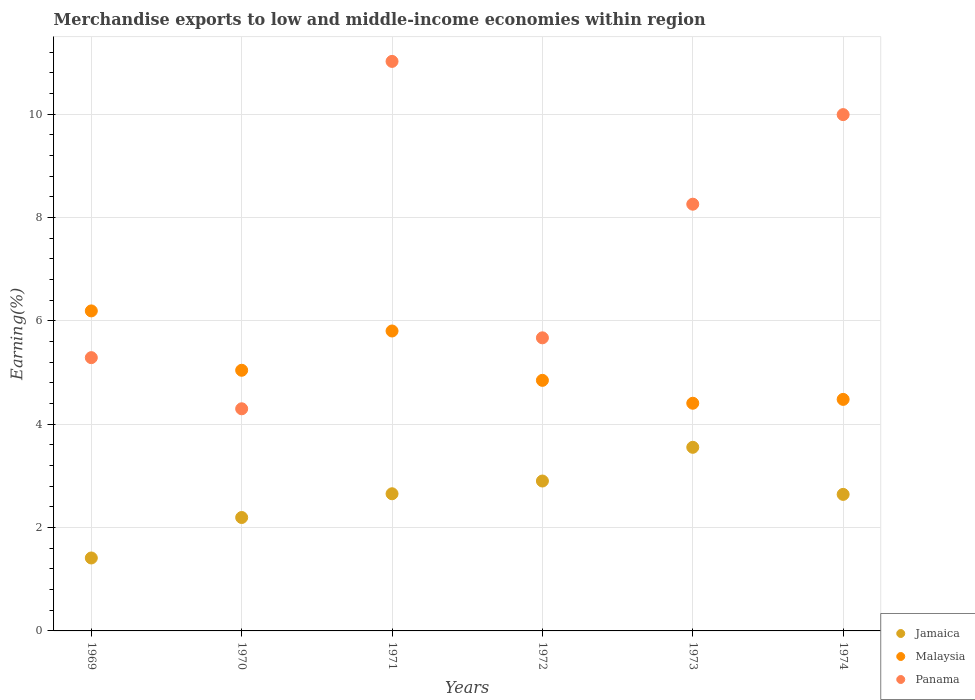Is the number of dotlines equal to the number of legend labels?
Make the answer very short. Yes. What is the percentage of amount earned from merchandise exports in Malaysia in 1971?
Give a very brief answer. 5.81. Across all years, what is the maximum percentage of amount earned from merchandise exports in Jamaica?
Your response must be concise. 3.55. Across all years, what is the minimum percentage of amount earned from merchandise exports in Jamaica?
Your answer should be very brief. 1.41. In which year was the percentage of amount earned from merchandise exports in Jamaica maximum?
Offer a terse response. 1973. What is the total percentage of amount earned from merchandise exports in Jamaica in the graph?
Your response must be concise. 15.36. What is the difference between the percentage of amount earned from merchandise exports in Malaysia in 1973 and that in 1974?
Provide a short and direct response. -0.07. What is the difference between the percentage of amount earned from merchandise exports in Panama in 1969 and the percentage of amount earned from merchandise exports in Jamaica in 1970?
Your answer should be very brief. 3.09. What is the average percentage of amount earned from merchandise exports in Panama per year?
Your answer should be compact. 7.42. In the year 1972, what is the difference between the percentage of amount earned from merchandise exports in Panama and percentage of amount earned from merchandise exports in Jamaica?
Give a very brief answer. 2.77. In how many years, is the percentage of amount earned from merchandise exports in Jamaica greater than 5.2 %?
Keep it short and to the point. 0. What is the ratio of the percentage of amount earned from merchandise exports in Jamaica in 1970 to that in 1971?
Provide a short and direct response. 0.83. Is the percentage of amount earned from merchandise exports in Malaysia in 1969 less than that in 1972?
Offer a terse response. No. What is the difference between the highest and the second highest percentage of amount earned from merchandise exports in Malaysia?
Keep it short and to the point. 0.39. What is the difference between the highest and the lowest percentage of amount earned from merchandise exports in Jamaica?
Give a very brief answer. 2.14. In how many years, is the percentage of amount earned from merchandise exports in Malaysia greater than the average percentage of amount earned from merchandise exports in Malaysia taken over all years?
Keep it short and to the point. 2. How many dotlines are there?
Ensure brevity in your answer.  3. How many years are there in the graph?
Provide a succinct answer. 6. What is the difference between two consecutive major ticks on the Y-axis?
Your response must be concise. 2. Does the graph contain grids?
Keep it short and to the point. Yes. Where does the legend appear in the graph?
Keep it short and to the point. Bottom right. What is the title of the graph?
Keep it short and to the point. Merchandise exports to low and middle-income economies within region. Does "Bosnia and Herzegovina" appear as one of the legend labels in the graph?
Keep it short and to the point. No. What is the label or title of the X-axis?
Offer a very short reply. Years. What is the label or title of the Y-axis?
Provide a succinct answer. Earning(%). What is the Earning(%) of Jamaica in 1969?
Ensure brevity in your answer.  1.41. What is the Earning(%) of Malaysia in 1969?
Ensure brevity in your answer.  6.19. What is the Earning(%) in Panama in 1969?
Your response must be concise. 5.29. What is the Earning(%) of Jamaica in 1970?
Your answer should be compact. 2.2. What is the Earning(%) in Malaysia in 1970?
Ensure brevity in your answer.  5.05. What is the Earning(%) of Panama in 1970?
Your answer should be compact. 4.3. What is the Earning(%) of Jamaica in 1971?
Your answer should be compact. 2.65. What is the Earning(%) of Malaysia in 1971?
Your answer should be very brief. 5.81. What is the Earning(%) in Panama in 1971?
Keep it short and to the point. 11.02. What is the Earning(%) of Jamaica in 1972?
Give a very brief answer. 2.9. What is the Earning(%) of Malaysia in 1972?
Your response must be concise. 4.85. What is the Earning(%) in Panama in 1972?
Offer a very short reply. 5.67. What is the Earning(%) in Jamaica in 1973?
Provide a succinct answer. 3.55. What is the Earning(%) of Malaysia in 1973?
Your answer should be very brief. 4.41. What is the Earning(%) in Panama in 1973?
Offer a terse response. 8.26. What is the Earning(%) of Jamaica in 1974?
Offer a terse response. 2.64. What is the Earning(%) of Malaysia in 1974?
Keep it short and to the point. 4.48. What is the Earning(%) in Panama in 1974?
Ensure brevity in your answer.  9.99. Across all years, what is the maximum Earning(%) in Jamaica?
Make the answer very short. 3.55. Across all years, what is the maximum Earning(%) in Malaysia?
Give a very brief answer. 6.19. Across all years, what is the maximum Earning(%) in Panama?
Provide a short and direct response. 11.02. Across all years, what is the minimum Earning(%) of Jamaica?
Provide a succinct answer. 1.41. Across all years, what is the minimum Earning(%) in Malaysia?
Provide a succinct answer. 4.41. Across all years, what is the minimum Earning(%) in Panama?
Keep it short and to the point. 4.3. What is the total Earning(%) in Jamaica in the graph?
Ensure brevity in your answer.  15.36. What is the total Earning(%) of Malaysia in the graph?
Your answer should be very brief. 30.78. What is the total Earning(%) of Panama in the graph?
Your answer should be compact. 44.54. What is the difference between the Earning(%) of Jamaica in 1969 and that in 1970?
Provide a succinct answer. -0.78. What is the difference between the Earning(%) in Malaysia in 1969 and that in 1970?
Your answer should be compact. 1.15. What is the difference between the Earning(%) of Panama in 1969 and that in 1970?
Offer a terse response. 0.99. What is the difference between the Earning(%) in Jamaica in 1969 and that in 1971?
Offer a terse response. -1.24. What is the difference between the Earning(%) in Malaysia in 1969 and that in 1971?
Provide a short and direct response. 0.39. What is the difference between the Earning(%) in Panama in 1969 and that in 1971?
Provide a succinct answer. -5.73. What is the difference between the Earning(%) in Jamaica in 1969 and that in 1972?
Provide a short and direct response. -1.49. What is the difference between the Earning(%) of Malaysia in 1969 and that in 1972?
Your answer should be compact. 1.34. What is the difference between the Earning(%) of Panama in 1969 and that in 1972?
Provide a succinct answer. -0.38. What is the difference between the Earning(%) of Jamaica in 1969 and that in 1973?
Keep it short and to the point. -2.14. What is the difference between the Earning(%) in Malaysia in 1969 and that in 1973?
Make the answer very short. 1.79. What is the difference between the Earning(%) in Panama in 1969 and that in 1973?
Provide a succinct answer. -2.97. What is the difference between the Earning(%) in Jamaica in 1969 and that in 1974?
Make the answer very short. -1.23. What is the difference between the Earning(%) of Malaysia in 1969 and that in 1974?
Your answer should be compact. 1.71. What is the difference between the Earning(%) in Panama in 1969 and that in 1974?
Make the answer very short. -4.7. What is the difference between the Earning(%) of Jamaica in 1970 and that in 1971?
Make the answer very short. -0.46. What is the difference between the Earning(%) of Malaysia in 1970 and that in 1971?
Provide a short and direct response. -0.76. What is the difference between the Earning(%) in Panama in 1970 and that in 1971?
Your answer should be compact. -6.72. What is the difference between the Earning(%) in Jamaica in 1970 and that in 1972?
Keep it short and to the point. -0.71. What is the difference between the Earning(%) of Malaysia in 1970 and that in 1972?
Your response must be concise. 0.2. What is the difference between the Earning(%) of Panama in 1970 and that in 1972?
Provide a short and direct response. -1.37. What is the difference between the Earning(%) in Jamaica in 1970 and that in 1973?
Provide a short and direct response. -1.36. What is the difference between the Earning(%) in Malaysia in 1970 and that in 1973?
Provide a short and direct response. 0.64. What is the difference between the Earning(%) in Panama in 1970 and that in 1973?
Provide a succinct answer. -3.96. What is the difference between the Earning(%) in Jamaica in 1970 and that in 1974?
Provide a short and direct response. -0.45. What is the difference between the Earning(%) of Malaysia in 1970 and that in 1974?
Make the answer very short. 0.56. What is the difference between the Earning(%) in Panama in 1970 and that in 1974?
Offer a very short reply. -5.69. What is the difference between the Earning(%) in Jamaica in 1971 and that in 1972?
Provide a succinct answer. -0.25. What is the difference between the Earning(%) in Malaysia in 1971 and that in 1972?
Offer a very short reply. 0.96. What is the difference between the Earning(%) in Panama in 1971 and that in 1972?
Your response must be concise. 5.35. What is the difference between the Earning(%) of Jamaica in 1971 and that in 1973?
Your answer should be very brief. -0.9. What is the difference between the Earning(%) of Malaysia in 1971 and that in 1973?
Make the answer very short. 1.4. What is the difference between the Earning(%) in Panama in 1971 and that in 1973?
Your answer should be compact. 2.76. What is the difference between the Earning(%) in Jamaica in 1971 and that in 1974?
Your answer should be compact. 0.01. What is the difference between the Earning(%) of Malaysia in 1971 and that in 1974?
Give a very brief answer. 1.32. What is the difference between the Earning(%) in Panama in 1971 and that in 1974?
Offer a very short reply. 1.03. What is the difference between the Earning(%) of Jamaica in 1972 and that in 1973?
Your response must be concise. -0.65. What is the difference between the Earning(%) of Malaysia in 1972 and that in 1973?
Make the answer very short. 0.44. What is the difference between the Earning(%) of Panama in 1972 and that in 1973?
Provide a short and direct response. -2.59. What is the difference between the Earning(%) in Jamaica in 1972 and that in 1974?
Keep it short and to the point. 0.26. What is the difference between the Earning(%) of Malaysia in 1972 and that in 1974?
Your answer should be compact. 0.37. What is the difference between the Earning(%) of Panama in 1972 and that in 1974?
Give a very brief answer. -4.32. What is the difference between the Earning(%) in Jamaica in 1973 and that in 1974?
Your answer should be compact. 0.91. What is the difference between the Earning(%) of Malaysia in 1973 and that in 1974?
Provide a succinct answer. -0.07. What is the difference between the Earning(%) in Panama in 1973 and that in 1974?
Give a very brief answer. -1.73. What is the difference between the Earning(%) of Jamaica in 1969 and the Earning(%) of Malaysia in 1970?
Make the answer very short. -3.63. What is the difference between the Earning(%) in Jamaica in 1969 and the Earning(%) in Panama in 1970?
Your response must be concise. -2.89. What is the difference between the Earning(%) of Malaysia in 1969 and the Earning(%) of Panama in 1970?
Make the answer very short. 1.89. What is the difference between the Earning(%) in Jamaica in 1969 and the Earning(%) in Malaysia in 1971?
Make the answer very short. -4.39. What is the difference between the Earning(%) of Jamaica in 1969 and the Earning(%) of Panama in 1971?
Offer a terse response. -9.61. What is the difference between the Earning(%) of Malaysia in 1969 and the Earning(%) of Panama in 1971?
Keep it short and to the point. -4.83. What is the difference between the Earning(%) of Jamaica in 1969 and the Earning(%) of Malaysia in 1972?
Ensure brevity in your answer.  -3.44. What is the difference between the Earning(%) in Jamaica in 1969 and the Earning(%) in Panama in 1972?
Provide a short and direct response. -4.26. What is the difference between the Earning(%) in Malaysia in 1969 and the Earning(%) in Panama in 1972?
Offer a terse response. 0.52. What is the difference between the Earning(%) in Jamaica in 1969 and the Earning(%) in Malaysia in 1973?
Offer a very short reply. -2.99. What is the difference between the Earning(%) of Jamaica in 1969 and the Earning(%) of Panama in 1973?
Provide a succinct answer. -6.85. What is the difference between the Earning(%) in Malaysia in 1969 and the Earning(%) in Panama in 1973?
Your response must be concise. -2.07. What is the difference between the Earning(%) in Jamaica in 1969 and the Earning(%) in Malaysia in 1974?
Offer a very short reply. -3.07. What is the difference between the Earning(%) in Jamaica in 1969 and the Earning(%) in Panama in 1974?
Make the answer very short. -8.58. What is the difference between the Earning(%) in Malaysia in 1969 and the Earning(%) in Panama in 1974?
Your response must be concise. -3.8. What is the difference between the Earning(%) in Jamaica in 1970 and the Earning(%) in Malaysia in 1971?
Ensure brevity in your answer.  -3.61. What is the difference between the Earning(%) in Jamaica in 1970 and the Earning(%) in Panama in 1971?
Keep it short and to the point. -8.83. What is the difference between the Earning(%) in Malaysia in 1970 and the Earning(%) in Panama in 1971?
Your answer should be compact. -5.98. What is the difference between the Earning(%) in Jamaica in 1970 and the Earning(%) in Malaysia in 1972?
Your answer should be compact. -2.65. What is the difference between the Earning(%) of Jamaica in 1970 and the Earning(%) of Panama in 1972?
Offer a very short reply. -3.48. What is the difference between the Earning(%) of Malaysia in 1970 and the Earning(%) of Panama in 1972?
Provide a succinct answer. -0.63. What is the difference between the Earning(%) of Jamaica in 1970 and the Earning(%) of Malaysia in 1973?
Provide a short and direct response. -2.21. What is the difference between the Earning(%) of Jamaica in 1970 and the Earning(%) of Panama in 1973?
Offer a very short reply. -6.06. What is the difference between the Earning(%) in Malaysia in 1970 and the Earning(%) in Panama in 1973?
Your answer should be very brief. -3.21. What is the difference between the Earning(%) of Jamaica in 1970 and the Earning(%) of Malaysia in 1974?
Your response must be concise. -2.29. What is the difference between the Earning(%) of Jamaica in 1970 and the Earning(%) of Panama in 1974?
Make the answer very short. -7.8. What is the difference between the Earning(%) in Malaysia in 1970 and the Earning(%) in Panama in 1974?
Your response must be concise. -4.95. What is the difference between the Earning(%) in Jamaica in 1971 and the Earning(%) in Malaysia in 1972?
Provide a short and direct response. -2.2. What is the difference between the Earning(%) of Jamaica in 1971 and the Earning(%) of Panama in 1972?
Give a very brief answer. -3.02. What is the difference between the Earning(%) in Malaysia in 1971 and the Earning(%) in Panama in 1972?
Offer a terse response. 0.13. What is the difference between the Earning(%) of Jamaica in 1971 and the Earning(%) of Malaysia in 1973?
Make the answer very short. -1.75. What is the difference between the Earning(%) in Jamaica in 1971 and the Earning(%) in Panama in 1973?
Offer a very short reply. -5.6. What is the difference between the Earning(%) in Malaysia in 1971 and the Earning(%) in Panama in 1973?
Provide a succinct answer. -2.45. What is the difference between the Earning(%) in Jamaica in 1971 and the Earning(%) in Malaysia in 1974?
Offer a terse response. -1.83. What is the difference between the Earning(%) of Jamaica in 1971 and the Earning(%) of Panama in 1974?
Make the answer very short. -7.34. What is the difference between the Earning(%) of Malaysia in 1971 and the Earning(%) of Panama in 1974?
Offer a very short reply. -4.19. What is the difference between the Earning(%) of Jamaica in 1972 and the Earning(%) of Malaysia in 1973?
Offer a terse response. -1.51. What is the difference between the Earning(%) of Jamaica in 1972 and the Earning(%) of Panama in 1973?
Make the answer very short. -5.36. What is the difference between the Earning(%) of Malaysia in 1972 and the Earning(%) of Panama in 1973?
Your answer should be compact. -3.41. What is the difference between the Earning(%) of Jamaica in 1972 and the Earning(%) of Malaysia in 1974?
Provide a short and direct response. -1.58. What is the difference between the Earning(%) of Jamaica in 1972 and the Earning(%) of Panama in 1974?
Offer a terse response. -7.09. What is the difference between the Earning(%) in Malaysia in 1972 and the Earning(%) in Panama in 1974?
Make the answer very short. -5.14. What is the difference between the Earning(%) of Jamaica in 1973 and the Earning(%) of Malaysia in 1974?
Your answer should be very brief. -0.93. What is the difference between the Earning(%) of Jamaica in 1973 and the Earning(%) of Panama in 1974?
Provide a short and direct response. -6.44. What is the difference between the Earning(%) in Malaysia in 1973 and the Earning(%) in Panama in 1974?
Your answer should be very brief. -5.59. What is the average Earning(%) in Jamaica per year?
Make the answer very short. 2.56. What is the average Earning(%) in Malaysia per year?
Provide a short and direct response. 5.13. What is the average Earning(%) of Panama per year?
Ensure brevity in your answer.  7.42. In the year 1969, what is the difference between the Earning(%) of Jamaica and Earning(%) of Malaysia?
Ensure brevity in your answer.  -4.78. In the year 1969, what is the difference between the Earning(%) of Jamaica and Earning(%) of Panama?
Ensure brevity in your answer.  -3.88. In the year 1969, what is the difference between the Earning(%) of Malaysia and Earning(%) of Panama?
Your response must be concise. 0.9. In the year 1970, what is the difference between the Earning(%) in Jamaica and Earning(%) in Malaysia?
Give a very brief answer. -2.85. In the year 1970, what is the difference between the Earning(%) of Jamaica and Earning(%) of Panama?
Ensure brevity in your answer.  -2.1. In the year 1970, what is the difference between the Earning(%) of Malaysia and Earning(%) of Panama?
Provide a succinct answer. 0.75. In the year 1971, what is the difference between the Earning(%) of Jamaica and Earning(%) of Malaysia?
Your answer should be compact. -3.15. In the year 1971, what is the difference between the Earning(%) of Jamaica and Earning(%) of Panama?
Keep it short and to the point. -8.37. In the year 1971, what is the difference between the Earning(%) in Malaysia and Earning(%) in Panama?
Provide a succinct answer. -5.22. In the year 1972, what is the difference between the Earning(%) in Jamaica and Earning(%) in Malaysia?
Give a very brief answer. -1.95. In the year 1972, what is the difference between the Earning(%) in Jamaica and Earning(%) in Panama?
Give a very brief answer. -2.77. In the year 1972, what is the difference between the Earning(%) in Malaysia and Earning(%) in Panama?
Provide a succinct answer. -0.82. In the year 1973, what is the difference between the Earning(%) in Jamaica and Earning(%) in Malaysia?
Your answer should be very brief. -0.85. In the year 1973, what is the difference between the Earning(%) in Jamaica and Earning(%) in Panama?
Give a very brief answer. -4.71. In the year 1973, what is the difference between the Earning(%) of Malaysia and Earning(%) of Panama?
Offer a very short reply. -3.85. In the year 1974, what is the difference between the Earning(%) of Jamaica and Earning(%) of Malaysia?
Keep it short and to the point. -1.84. In the year 1974, what is the difference between the Earning(%) in Jamaica and Earning(%) in Panama?
Your answer should be compact. -7.35. In the year 1974, what is the difference between the Earning(%) in Malaysia and Earning(%) in Panama?
Provide a short and direct response. -5.51. What is the ratio of the Earning(%) in Jamaica in 1969 to that in 1970?
Offer a terse response. 0.64. What is the ratio of the Earning(%) of Malaysia in 1969 to that in 1970?
Your response must be concise. 1.23. What is the ratio of the Earning(%) of Panama in 1969 to that in 1970?
Give a very brief answer. 1.23. What is the ratio of the Earning(%) in Jamaica in 1969 to that in 1971?
Your response must be concise. 0.53. What is the ratio of the Earning(%) in Malaysia in 1969 to that in 1971?
Offer a terse response. 1.07. What is the ratio of the Earning(%) in Panama in 1969 to that in 1971?
Your answer should be compact. 0.48. What is the ratio of the Earning(%) in Jamaica in 1969 to that in 1972?
Your response must be concise. 0.49. What is the ratio of the Earning(%) of Malaysia in 1969 to that in 1972?
Offer a very short reply. 1.28. What is the ratio of the Earning(%) of Panama in 1969 to that in 1972?
Provide a succinct answer. 0.93. What is the ratio of the Earning(%) in Jamaica in 1969 to that in 1973?
Offer a terse response. 0.4. What is the ratio of the Earning(%) of Malaysia in 1969 to that in 1973?
Ensure brevity in your answer.  1.41. What is the ratio of the Earning(%) of Panama in 1969 to that in 1973?
Your answer should be compact. 0.64. What is the ratio of the Earning(%) of Jamaica in 1969 to that in 1974?
Provide a succinct answer. 0.53. What is the ratio of the Earning(%) in Malaysia in 1969 to that in 1974?
Provide a succinct answer. 1.38. What is the ratio of the Earning(%) of Panama in 1969 to that in 1974?
Your response must be concise. 0.53. What is the ratio of the Earning(%) in Jamaica in 1970 to that in 1971?
Your answer should be compact. 0.83. What is the ratio of the Earning(%) in Malaysia in 1970 to that in 1971?
Keep it short and to the point. 0.87. What is the ratio of the Earning(%) of Panama in 1970 to that in 1971?
Your response must be concise. 0.39. What is the ratio of the Earning(%) in Jamaica in 1970 to that in 1972?
Your answer should be compact. 0.76. What is the ratio of the Earning(%) of Malaysia in 1970 to that in 1972?
Make the answer very short. 1.04. What is the ratio of the Earning(%) in Panama in 1970 to that in 1972?
Provide a short and direct response. 0.76. What is the ratio of the Earning(%) of Jamaica in 1970 to that in 1973?
Keep it short and to the point. 0.62. What is the ratio of the Earning(%) of Malaysia in 1970 to that in 1973?
Provide a succinct answer. 1.14. What is the ratio of the Earning(%) in Panama in 1970 to that in 1973?
Keep it short and to the point. 0.52. What is the ratio of the Earning(%) of Jamaica in 1970 to that in 1974?
Give a very brief answer. 0.83. What is the ratio of the Earning(%) in Malaysia in 1970 to that in 1974?
Provide a succinct answer. 1.13. What is the ratio of the Earning(%) of Panama in 1970 to that in 1974?
Keep it short and to the point. 0.43. What is the ratio of the Earning(%) of Jamaica in 1971 to that in 1972?
Give a very brief answer. 0.92. What is the ratio of the Earning(%) in Malaysia in 1971 to that in 1972?
Your answer should be compact. 1.2. What is the ratio of the Earning(%) of Panama in 1971 to that in 1972?
Provide a short and direct response. 1.94. What is the ratio of the Earning(%) of Jamaica in 1971 to that in 1973?
Your answer should be very brief. 0.75. What is the ratio of the Earning(%) in Malaysia in 1971 to that in 1973?
Your answer should be very brief. 1.32. What is the ratio of the Earning(%) in Panama in 1971 to that in 1973?
Your answer should be compact. 1.33. What is the ratio of the Earning(%) of Jamaica in 1971 to that in 1974?
Your answer should be compact. 1. What is the ratio of the Earning(%) in Malaysia in 1971 to that in 1974?
Offer a very short reply. 1.3. What is the ratio of the Earning(%) of Panama in 1971 to that in 1974?
Make the answer very short. 1.1. What is the ratio of the Earning(%) of Jamaica in 1972 to that in 1973?
Give a very brief answer. 0.82. What is the ratio of the Earning(%) in Malaysia in 1972 to that in 1973?
Give a very brief answer. 1.1. What is the ratio of the Earning(%) of Panama in 1972 to that in 1973?
Your answer should be compact. 0.69. What is the ratio of the Earning(%) of Jamaica in 1972 to that in 1974?
Your answer should be compact. 1.1. What is the ratio of the Earning(%) in Malaysia in 1972 to that in 1974?
Give a very brief answer. 1.08. What is the ratio of the Earning(%) of Panama in 1972 to that in 1974?
Offer a very short reply. 0.57. What is the ratio of the Earning(%) of Jamaica in 1973 to that in 1974?
Give a very brief answer. 1.34. What is the ratio of the Earning(%) in Malaysia in 1973 to that in 1974?
Provide a succinct answer. 0.98. What is the ratio of the Earning(%) in Panama in 1973 to that in 1974?
Your response must be concise. 0.83. What is the difference between the highest and the second highest Earning(%) of Jamaica?
Provide a short and direct response. 0.65. What is the difference between the highest and the second highest Earning(%) of Malaysia?
Provide a short and direct response. 0.39. What is the difference between the highest and the second highest Earning(%) in Panama?
Make the answer very short. 1.03. What is the difference between the highest and the lowest Earning(%) in Jamaica?
Offer a terse response. 2.14. What is the difference between the highest and the lowest Earning(%) in Malaysia?
Your answer should be very brief. 1.79. What is the difference between the highest and the lowest Earning(%) in Panama?
Give a very brief answer. 6.72. 